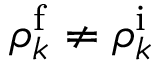Convert formula to latex. <formula><loc_0><loc_0><loc_500><loc_500>\rho _ { k } ^ { \mathrm f } \neq \rho _ { k } ^ { \mathrm i }</formula> 